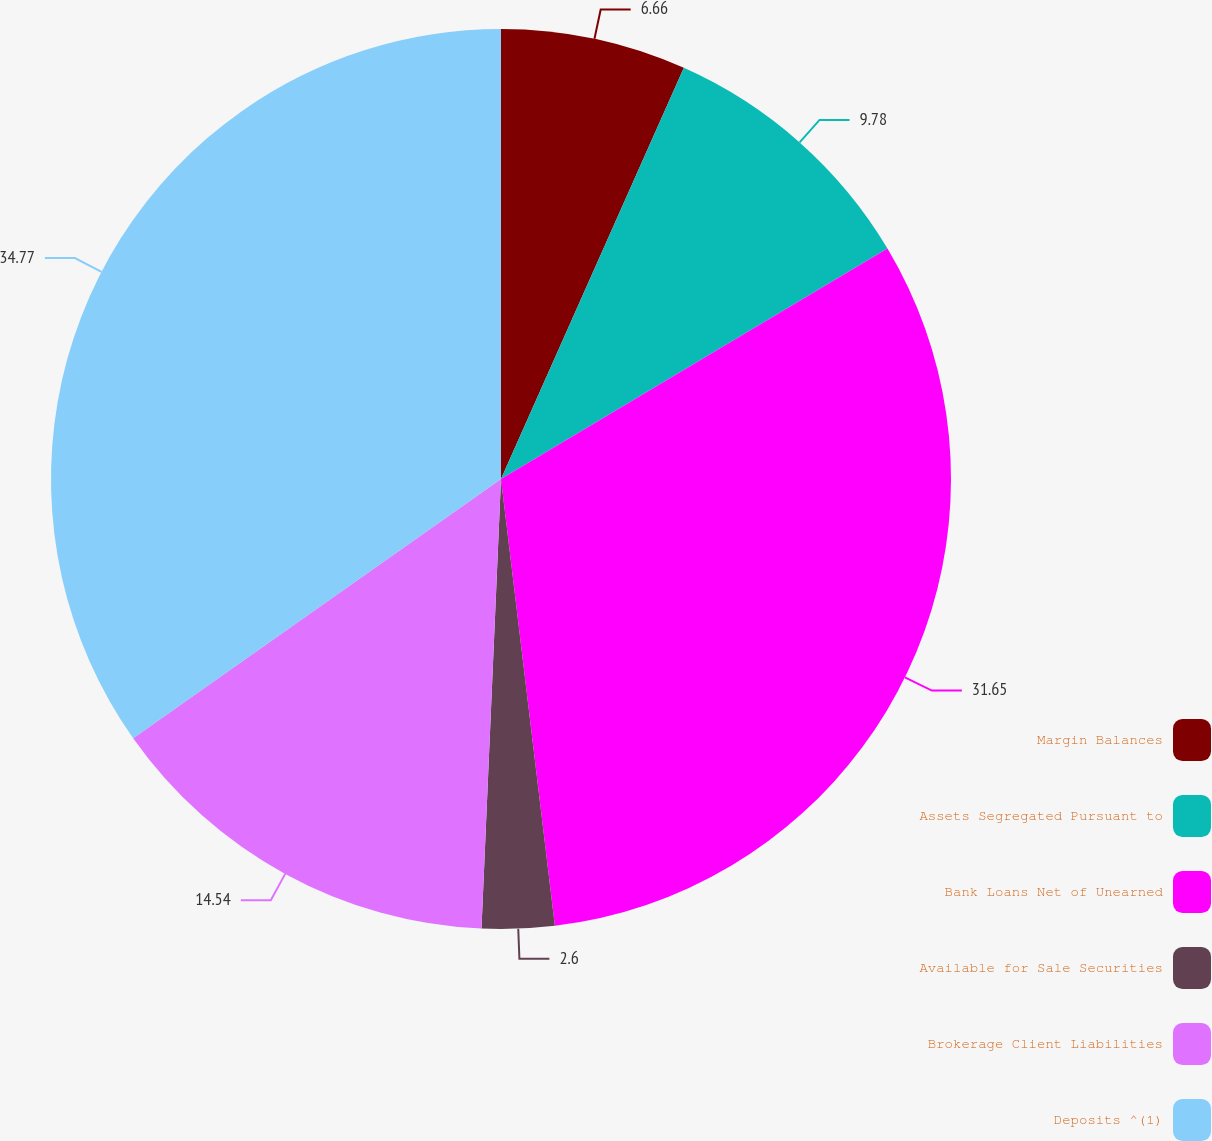Convert chart to OTSL. <chart><loc_0><loc_0><loc_500><loc_500><pie_chart><fcel>Margin Balances<fcel>Assets Segregated Pursuant to<fcel>Bank Loans Net of Unearned<fcel>Available for Sale Securities<fcel>Brokerage Client Liabilities<fcel>Deposits ^(1)<nl><fcel>6.66%<fcel>9.78%<fcel>31.65%<fcel>2.6%<fcel>14.54%<fcel>34.77%<nl></chart> 